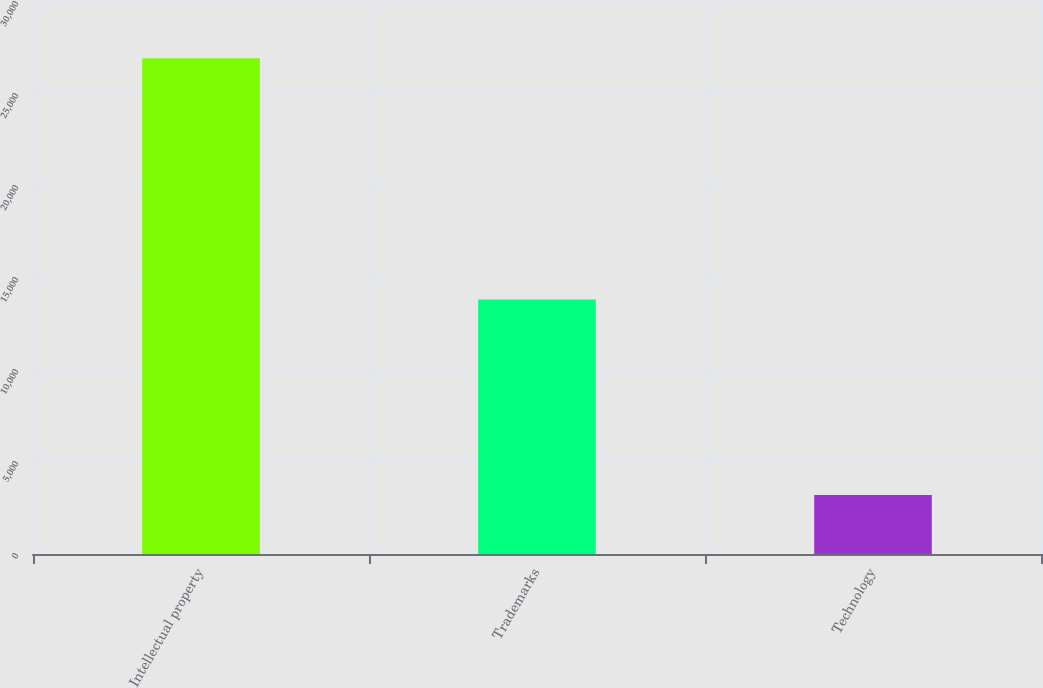Convert chart. <chart><loc_0><loc_0><loc_500><loc_500><bar_chart><fcel>Intellectual property<fcel>Trademarks<fcel>Technology<nl><fcel>26949<fcel>13838<fcel>3200<nl></chart> 